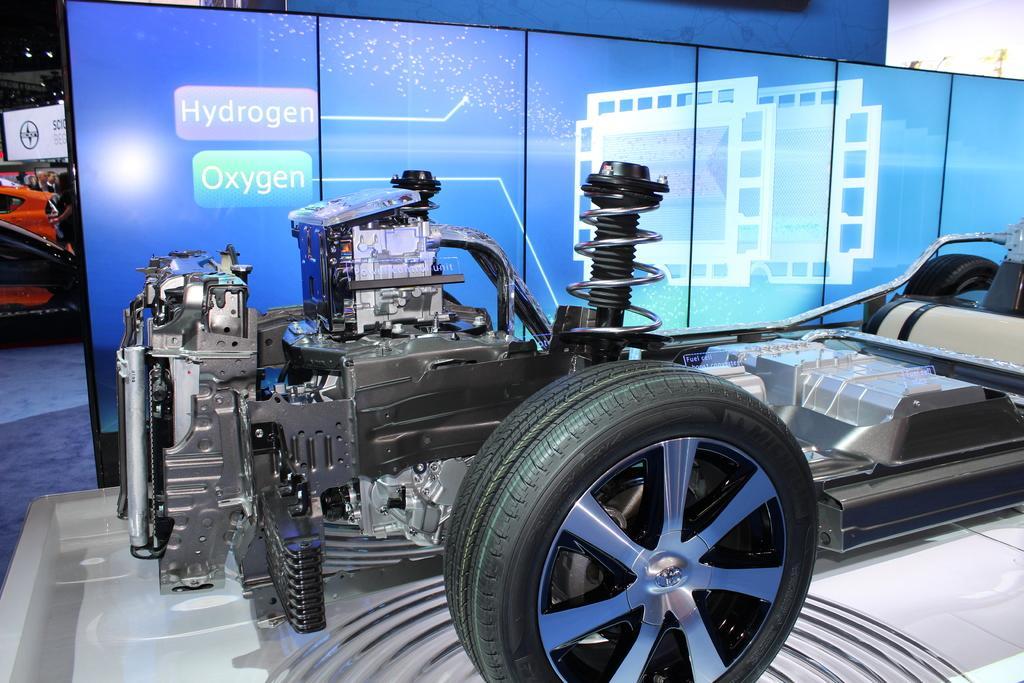How would you summarize this image in a sentence or two? In this image we can see inside part of a sports car. There is engine and some other machines. We can see tyre and seat. There is a partition wall. There is another red color car. 